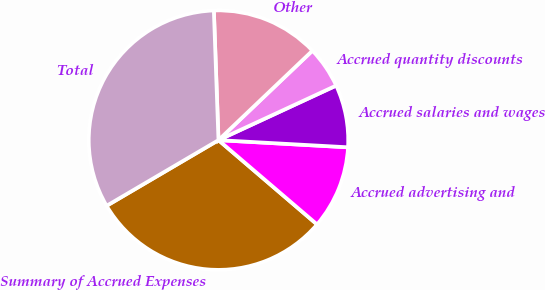Convert chart. <chart><loc_0><loc_0><loc_500><loc_500><pie_chart><fcel>Summary of Accrued Expenses<fcel>Accrued advertising and<fcel>Accrued salaries and wages<fcel>Accrued quantity discounts<fcel>Other<fcel>Total<nl><fcel>30.29%<fcel>10.38%<fcel>7.79%<fcel>5.2%<fcel>13.46%<fcel>32.88%<nl></chart> 